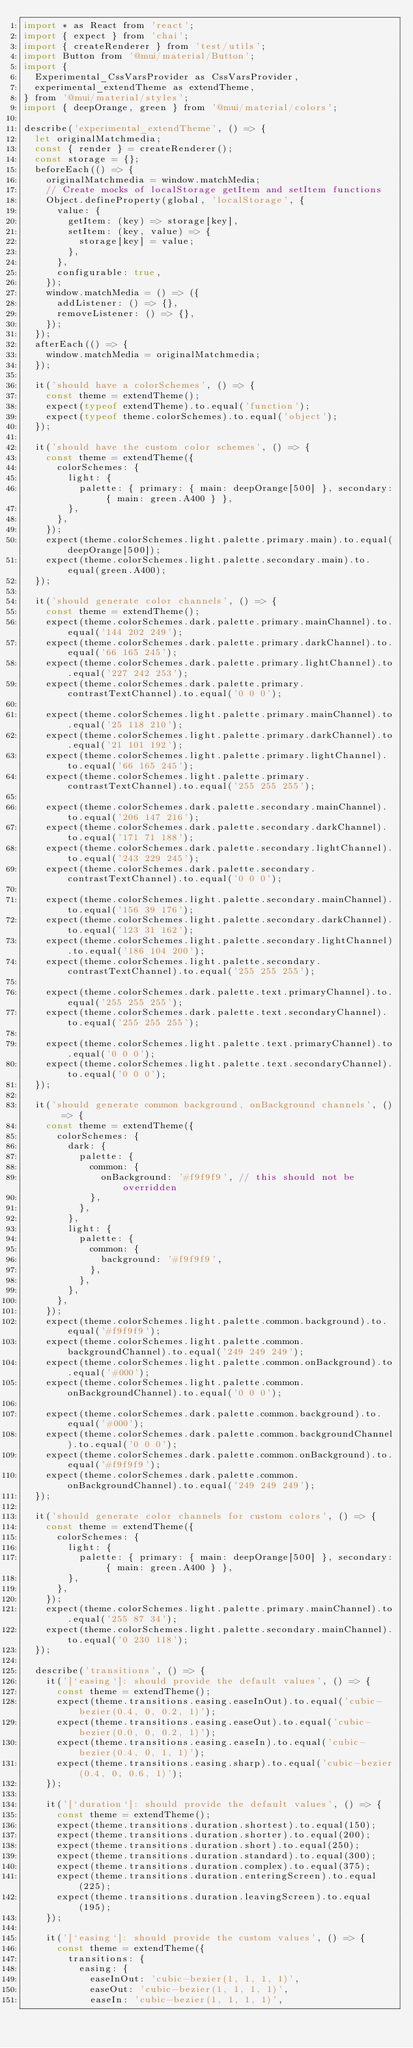Convert code to text. <code><loc_0><loc_0><loc_500><loc_500><_JavaScript_>import * as React from 'react';
import { expect } from 'chai';
import { createRenderer } from 'test/utils';
import Button from '@mui/material/Button';
import {
  Experimental_CssVarsProvider as CssVarsProvider,
  experimental_extendTheme as extendTheme,
} from '@mui/material/styles';
import { deepOrange, green } from '@mui/material/colors';

describe('experimental_extendTheme', () => {
  let originalMatchmedia;
  const { render } = createRenderer();
  const storage = {};
  beforeEach(() => {
    originalMatchmedia = window.matchMedia;
    // Create mocks of localStorage getItem and setItem functions
    Object.defineProperty(global, 'localStorage', {
      value: {
        getItem: (key) => storage[key],
        setItem: (key, value) => {
          storage[key] = value;
        },
      },
      configurable: true,
    });
    window.matchMedia = () => ({
      addListener: () => {},
      removeListener: () => {},
    });
  });
  afterEach(() => {
    window.matchMedia = originalMatchmedia;
  });

  it('should have a colorSchemes', () => {
    const theme = extendTheme();
    expect(typeof extendTheme).to.equal('function');
    expect(typeof theme.colorSchemes).to.equal('object');
  });

  it('should have the custom color schemes', () => {
    const theme = extendTheme({
      colorSchemes: {
        light: {
          palette: { primary: { main: deepOrange[500] }, secondary: { main: green.A400 } },
        },
      },
    });
    expect(theme.colorSchemes.light.palette.primary.main).to.equal(deepOrange[500]);
    expect(theme.colorSchemes.light.palette.secondary.main).to.equal(green.A400);
  });

  it('should generate color channels', () => {
    const theme = extendTheme();
    expect(theme.colorSchemes.dark.palette.primary.mainChannel).to.equal('144 202 249');
    expect(theme.colorSchemes.dark.palette.primary.darkChannel).to.equal('66 165 245');
    expect(theme.colorSchemes.dark.palette.primary.lightChannel).to.equal('227 242 253');
    expect(theme.colorSchemes.dark.palette.primary.contrastTextChannel).to.equal('0 0 0');

    expect(theme.colorSchemes.light.palette.primary.mainChannel).to.equal('25 118 210');
    expect(theme.colorSchemes.light.palette.primary.darkChannel).to.equal('21 101 192');
    expect(theme.colorSchemes.light.palette.primary.lightChannel).to.equal('66 165 245');
    expect(theme.colorSchemes.light.palette.primary.contrastTextChannel).to.equal('255 255 255');

    expect(theme.colorSchemes.dark.palette.secondary.mainChannel).to.equal('206 147 216');
    expect(theme.colorSchemes.dark.palette.secondary.darkChannel).to.equal('171 71 188');
    expect(theme.colorSchemes.dark.palette.secondary.lightChannel).to.equal('243 229 245');
    expect(theme.colorSchemes.dark.palette.secondary.contrastTextChannel).to.equal('0 0 0');

    expect(theme.colorSchemes.light.palette.secondary.mainChannel).to.equal('156 39 176');
    expect(theme.colorSchemes.light.palette.secondary.darkChannel).to.equal('123 31 162');
    expect(theme.colorSchemes.light.palette.secondary.lightChannel).to.equal('186 104 200');
    expect(theme.colorSchemes.light.palette.secondary.contrastTextChannel).to.equal('255 255 255');

    expect(theme.colorSchemes.dark.palette.text.primaryChannel).to.equal('255 255 255');
    expect(theme.colorSchemes.dark.palette.text.secondaryChannel).to.equal('255 255 255');

    expect(theme.colorSchemes.light.palette.text.primaryChannel).to.equal('0 0 0');
    expect(theme.colorSchemes.light.palette.text.secondaryChannel).to.equal('0 0 0');
  });

  it('should generate common background, onBackground channels', () => {
    const theme = extendTheme({
      colorSchemes: {
        dark: {
          palette: {
            common: {
              onBackground: '#f9f9f9', // this should not be overridden
            },
          },
        },
        light: {
          palette: {
            common: {
              background: '#f9f9f9',
            },
          },
        },
      },
    });
    expect(theme.colorSchemes.light.palette.common.background).to.equal('#f9f9f9');
    expect(theme.colorSchemes.light.palette.common.backgroundChannel).to.equal('249 249 249');
    expect(theme.colorSchemes.light.palette.common.onBackground).to.equal('#000');
    expect(theme.colorSchemes.light.palette.common.onBackgroundChannel).to.equal('0 0 0');

    expect(theme.colorSchemes.dark.palette.common.background).to.equal('#000');
    expect(theme.colorSchemes.dark.palette.common.backgroundChannel).to.equal('0 0 0');
    expect(theme.colorSchemes.dark.palette.common.onBackground).to.equal('#f9f9f9');
    expect(theme.colorSchemes.dark.palette.common.onBackgroundChannel).to.equal('249 249 249');
  });

  it('should generate color channels for custom colors', () => {
    const theme = extendTheme({
      colorSchemes: {
        light: {
          palette: { primary: { main: deepOrange[500] }, secondary: { main: green.A400 } },
        },
      },
    });
    expect(theme.colorSchemes.light.palette.primary.mainChannel).to.equal('255 87 34');
    expect(theme.colorSchemes.light.palette.secondary.mainChannel).to.equal('0 230 118');
  });

  describe('transitions', () => {
    it('[`easing`]: should provide the default values', () => {
      const theme = extendTheme();
      expect(theme.transitions.easing.easeInOut).to.equal('cubic-bezier(0.4, 0, 0.2, 1)');
      expect(theme.transitions.easing.easeOut).to.equal('cubic-bezier(0.0, 0, 0.2, 1)');
      expect(theme.transitions.easing.easeIn).to.equal('cubic-bezier(0.4, 0, 1, 1)');
      expect(theme.transitions.easing.sharp).to.equal('cubic-bezier(0.4, 0, 0.6, 1)');
    });

    it('[`duration`]: should provide the default values', () => {
      const theme = extendTheme();
      expect(theme.transitions.duration.shortest).to.equal(150);
      expect(theme.transitions.duration.shorter).to.equal(200);
      expect(theme.transitions.duration.short).to.equal(250);
      expect(theme.transitions.duration.standard).to.equal(300);
      expect(theme.transitions.duration.complex).to.equal(375);
      expect(theme.transitions.duration.enteringScreen).to.equal(225);
      expect(theme.transitions.duration.leavingScreen).to.equal(195);
    });

    it('[`easing`]: should provide the custom values', () => {
      const theme = extendTheme({
        transitions: {
          easing: {
            easeInOut: 'cubic-bezier(1, 1, 1, 1)',
            easeOut: 'cubic-bezier(1, 1, 1, 1)',
            easeIn: 'cubic-bezier(1, 1, 1, 1)',</code> 